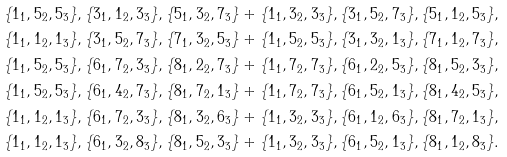<formula> <loc_0><loc_0><loc_500><loc_500>\{ 1 _ { 1 } , 5 _ { 2 } , 5 _ { 3 } \} , \{ 3 _ { 1 } , 1 _ { 2 } , 3 _ { 3 } \} , \{ 5 _ { 1 } , 3 _ { 2 } , 7 _ { 3 } \} + \{ 1 _ { 1 } , 3 _ { 2 } , 3 _ { 3 } \} , \{ 3 _ { 1 } , 5 _ { 2 } , 7 _ { 3 } \} , \{ 5 _ { 1 } , 1 _ { 2 } , 5 _ { 3 } \} , \\ \{ 1 _ { 1 } , 1 _ { 2 } , 1 _ { 3 } \} , \{ 3 _ { 1 } , 5 _ { 2 } , 7 _ { 3 } \} , \{ 7 _ { 1 } , 3 _ { 2 } , 5 _ { 3 } \} + \{ 1 _ { 1 } , 5 _ { 2 } , 5 _ { 3 } \} , \{ 3 _ { 1 } , 3 _ { 2 } , 1 _ { 3 } \} , \{ 7 _ { 1 } , 1 _ { 2 } , 7 _ { 3 } \} , \\ \{ 1 _ { 1 } , 5 _ { 2 } , 5 _ { 3 } \} , \{ 6 _ { 1 } , 7 _ { 2 } , 3 _ { 3 } \} , \{ 8 _ { 1 } , 2 _ { 2 } , 7 _ { 3 } \} + \{ 1 _ { 1 } , 7 _ { 2 } , 7 _ { 3 } \} , \{ 6 _ { 1 } , 2 _ { 2 } , 5 _ { 3 } \} , \{ 8 _ { 1 } , 5 _ { 2 } , 3 _ { 3 } \} , \\ \{ 1 _ { 1 } , 5 _ { 2 } , 5 _ { 3 } \} , \{ 6 _ { 1 } , 4 _ { 2 } , 7 _ { 3 } \} , \{ 8 _ { 1 } , 7 _ { 2 } , 1 _ { 3 } \} + \{ 1 _ { 1 } , 7 _ { 2 } , 7 _ { 3 } \} , \{ 6 _ { 1 } , 5 _ { 2 } , 1 _ { 3 } \} , \{ 8 _ { 1 } , 4 _ { 2 } , 5 _ { 3 } \} , \\ \{ 1 _ { 1 } , 1 _ { 2 } , 1 _ { 3 } \} , \{ 6 _ { 1 } , 7 _ { 2 } , 3 _ { 3 } \} , \{ 8 _ { 1 } , 3 _ { 2 } , 6 _ { 3 } \} + \{ 1 _ { 1 } , 3 _ { 2 } , 3 _ { 3 } \} , \{ 6 _ { 1 } , 1 _ { 2 } , 6 _ { 3 } \} , \{ 8 _ { 1 } , 7 _ { 2 } , 1 _ { 3 } \} , \\ \{ 1 _ { 1 } , 1 _ { 2 } , 1 _ { 3 } \} , \{ 6 _ { 1 } , 3 _ { 2 } , 8 _ { 3 } \} , \{ 8 _ { 1 } , 5 _ { 2 } , 3 _ { 3 } \} + \{ 1 _ { 1 } , 3 _ { 2 } , 3 _ { 3 } \} , \{ 6 _ { 1 } , 5 _ { 2 } , 1 _ { 3 } \} , \{ 8 _ { 1 } , 1 _ { 2 } , 8 _ { 3 } \} .</formula> 